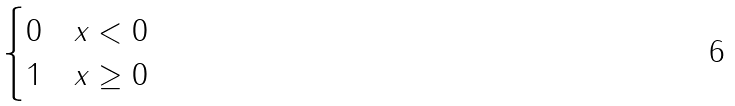Convert formula to latex. <formula><loc_0><loc_0><loc_500><loc_500>\begin{cases} 0 & x < 0 \\ 1 & x \geq 0 \end{cases}</formula> 